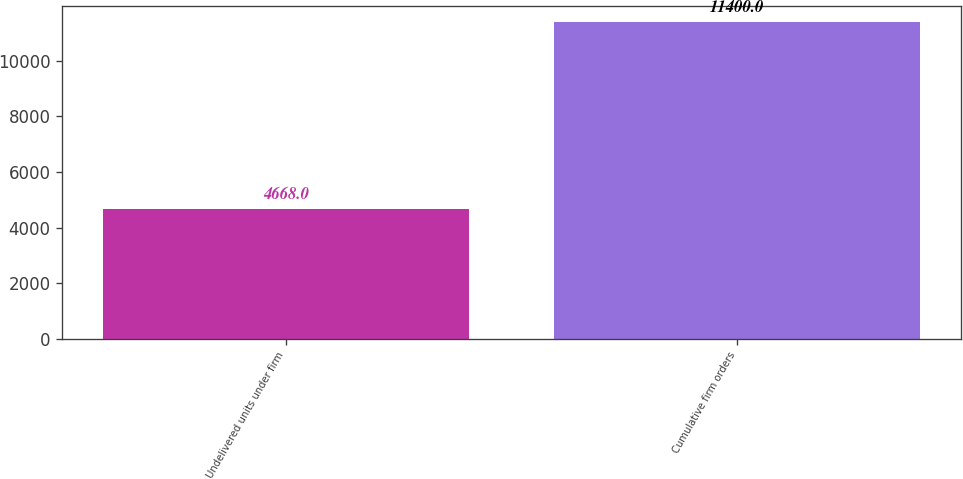Convert chart. <chart><loc_0><loc_0><loc_500><loc_500><bar_chart><fcel>Undelivered units under firm<fcel>Cumulative firm orders<nl><fcel>4668<fcel>11400<nl></chart> 